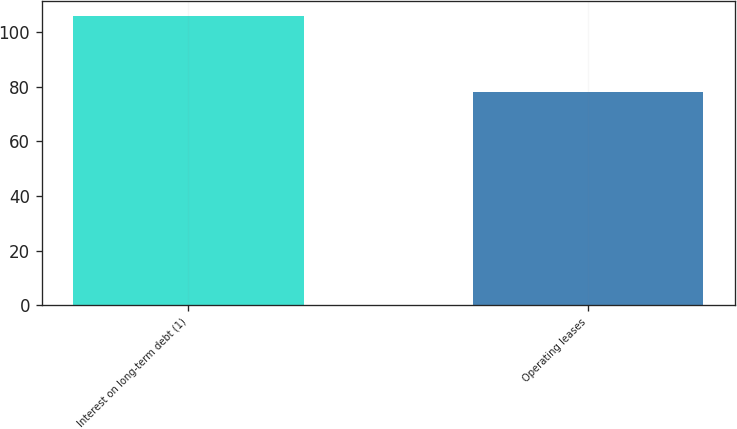<chart> <loc_0><loc_0><loc_500><loc_500><bar_chart><fcel>Interest on long-term debt (1)<fcel>Operating leases<nl><fcel>106<fcel>78<nl></chart> 